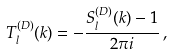Convert formula to latex. <formula><loc_0><loc_0><loc_500><loc_500>T _ { l } ^ { ( D ) } ( k ) = - \frac { S _ { l } ^ { ( D ) } ( k ) - 1 } { 2 \pi i } \, ,</formula> 